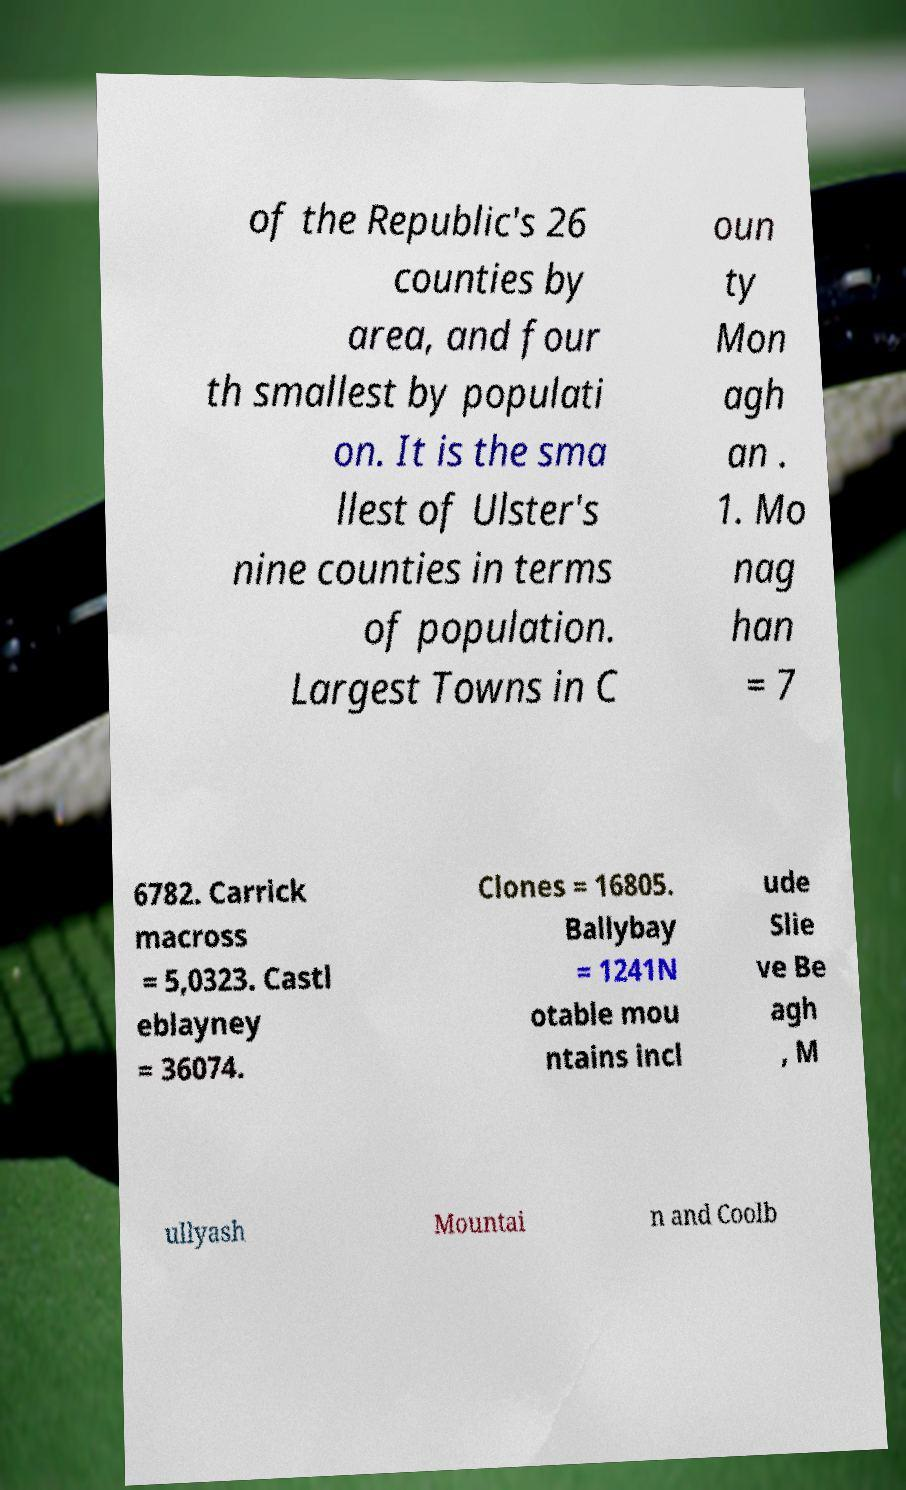Could you extract and type out the text from this image? of the Republic's 26 counties by area, and four th smallest by populati on. It is the sma llest of Ulster's nine counties in terms of population. Largest Towns in C oun ty Mon agh an . 1. Mo nag han = 7 6782. Carrick macross = 5,0323. Castl eblayney = 36074. Clones = 16805. Ballybay = 1241N otable mou ntains incl ude Slie ve Be agh , M ullyash Mountai n and Coolb 